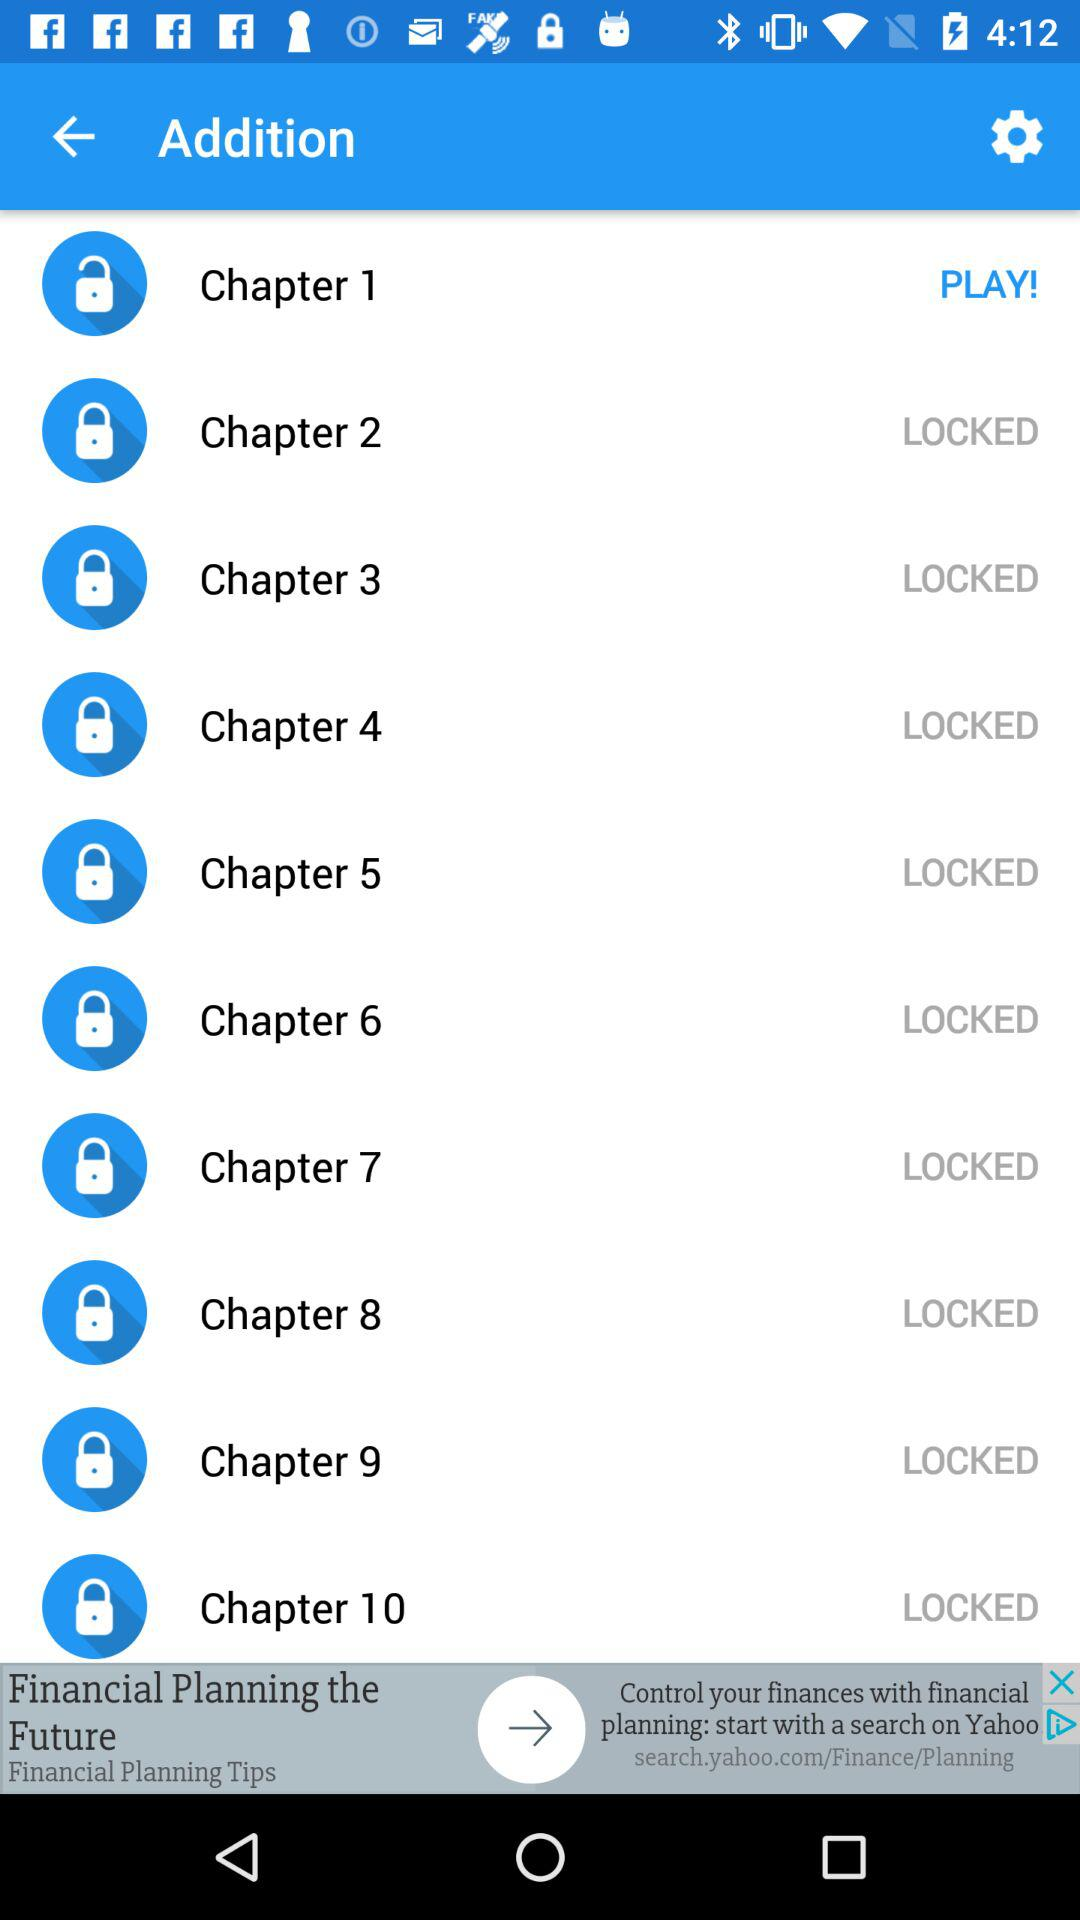What is the duration of "Chapter 3"?
When the provided information is insufficient, respond with <no answer>. <no answer> 